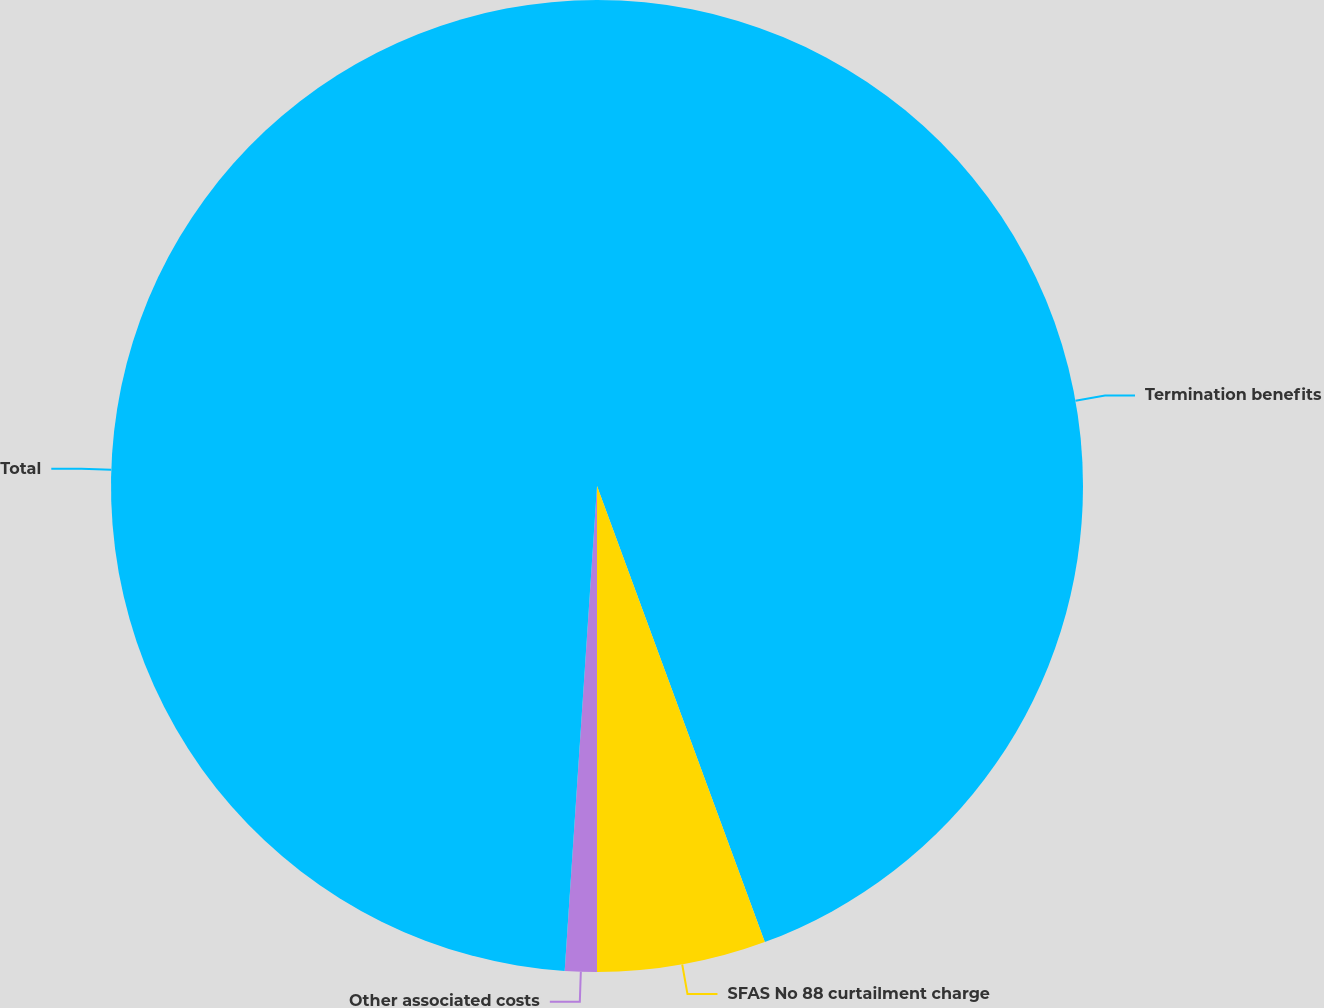<chart> <loc_0><loc_0><loc_500><loc_500><pie_chart><fcel>Termination benefits<fcel>SFAS No 88 curtailment charge<fcel>Other associated costs<fcel>Total<nl><fcel>44.39%<fcel>5.61%<fcel>1.06%<fcel>48.94%<nl></chart> 